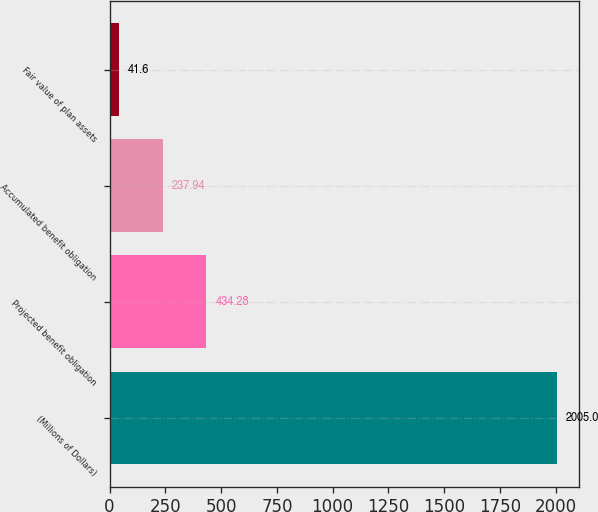<chart> <loc_0><loc_0><loc_500><loc_500><bar_chart><fcel>(Millions of Dollars)<fcel>Projected benefit obligation<fcel>Accumulated benefit obligation<fcel>Fair value of plan assets<nl><fcel>2005<fcel>434.28<fcel>237.94<fcel>41.6<nl></chart> 